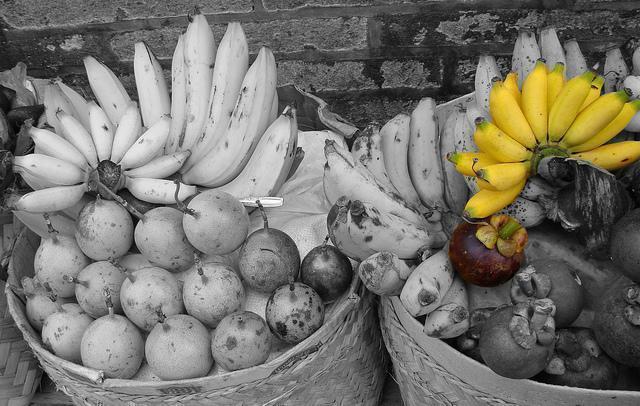Where is this produce located?
Select the accurate answer and provide explanation: 'Answer: answer
Rationale: rationale.'
Options: Market, store, refrigerator, driveway. Answer: market.
Rationale: There are two buckets of produce. it appears to be outside and dirty. 